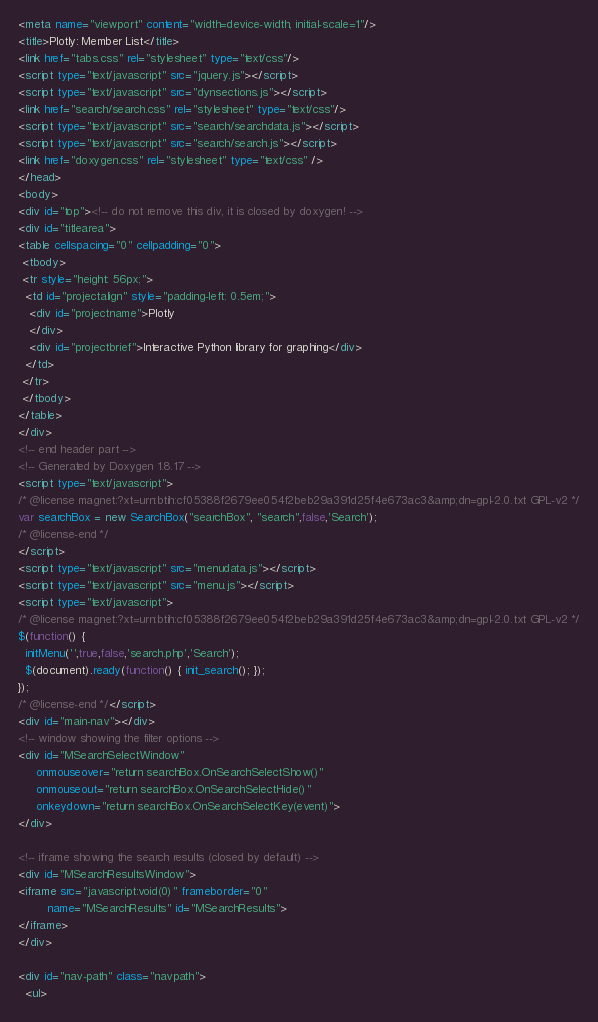<code> <loc_0><loc_0><loc_500><loc_500><_HTML_><meta name="viewport" content="width=device-width, initial-scale=1"/>
<title>Plotly: Member List</title>
<link href="tabs.css" rel="stylesheet" type="text/css"/>
<script type="text/javascript" src="jquery.js"></script>
<script type="text/javascript" src="dynsections.js"></script>
<link href="search/search.css" rel="stylesheet" type="text/css"/>
<script type="text/javascript" src="search/searchdata.js"></script>
<script type="text/javascript" src="search/search.js"></script>
<link href="doxygen.css" rel="stylesheet" type="text/css" />
</head>
<body>
<div id="top"><!-- do not remove this div, it is closed by doxygen! -->
<div id="titlearea">
<table cellspacing="0" cellpadding="0">
 <tbody>
 <tr style="height: 56px;">
  <td id="projectalign" style="padding-left: 0.5em;">
   <div id="projectname">Plotly
   </div>
   <div id="projectbrief">Interactive Python library for graphing</div>
  </td>
 </tr>
 </tbody>
</table>
</div>
<!-- end header part -->
<!-- Generated by Doxygen 1.8.17 -->
<script type="text/javascript">
/* @license magnet:?xt=urn:btih:cf05388f2679ee054f2beb29a391d25f4e673ac3&amp;dn=gpl-2.0.txt GPL-v2 */
var searchBox = new SearchBox("searchBox", "search",false,'Search');
/* @license-end */
</script>
<script type="text/javascript" src="menudata.js"></script>
<script type="text/javascript" src="menu.js"></script>
<script type="text/javascript">
/* @license magnet:?xt=urn:btih:cf05388f2679ee054f2beb29a391d25f4e673ac3&amp;dn=gpl-2.0.txt GPL-v2 */
$(function() {
  initMenu('',true,false,'search.php','Search');
  $(document).ready(function() { init_search(); });
});
/* @license-end */</script>
<div id="main-nav"></div>
<!-- window showing the filter options -->
<div id="MSearchSelectWindow"
     onmouseover="return searchBox.OnSearchSelectShow()"
     onmouseout="return searchBox.OnSearchSelectHide()"
     onkeydown="return searchBox.OnSearchSelectKey(event)">
</div>

<!-- iframe showing the search results (closed by default) -->
<div id="MSearchResultsWindow">
<iframe src="javascript:void(0)" frameborder="0" 
        name="MSearchResults" id="MSearchResults">
</iframe>
</div>

<div id="nav-path" class="navpath">
  <ul></code> 